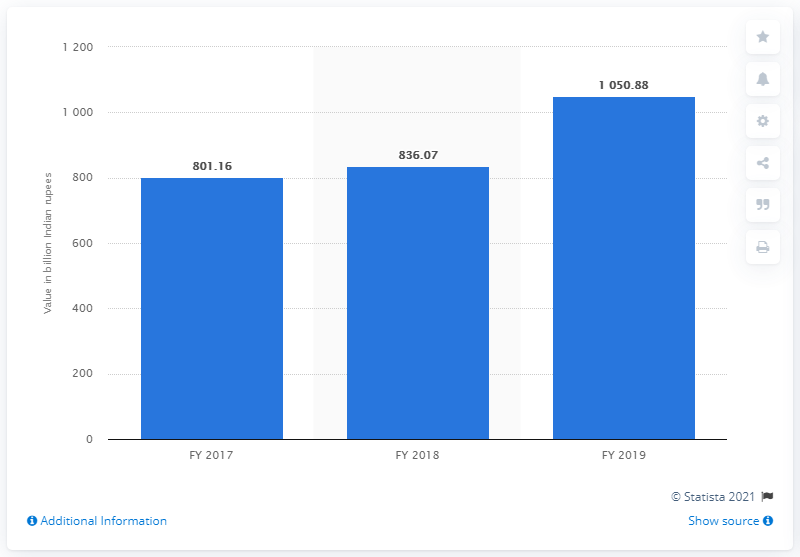Specify some key components in this picture. In 2017, Standard Chartered Bank deposited 801.16 rupees. 